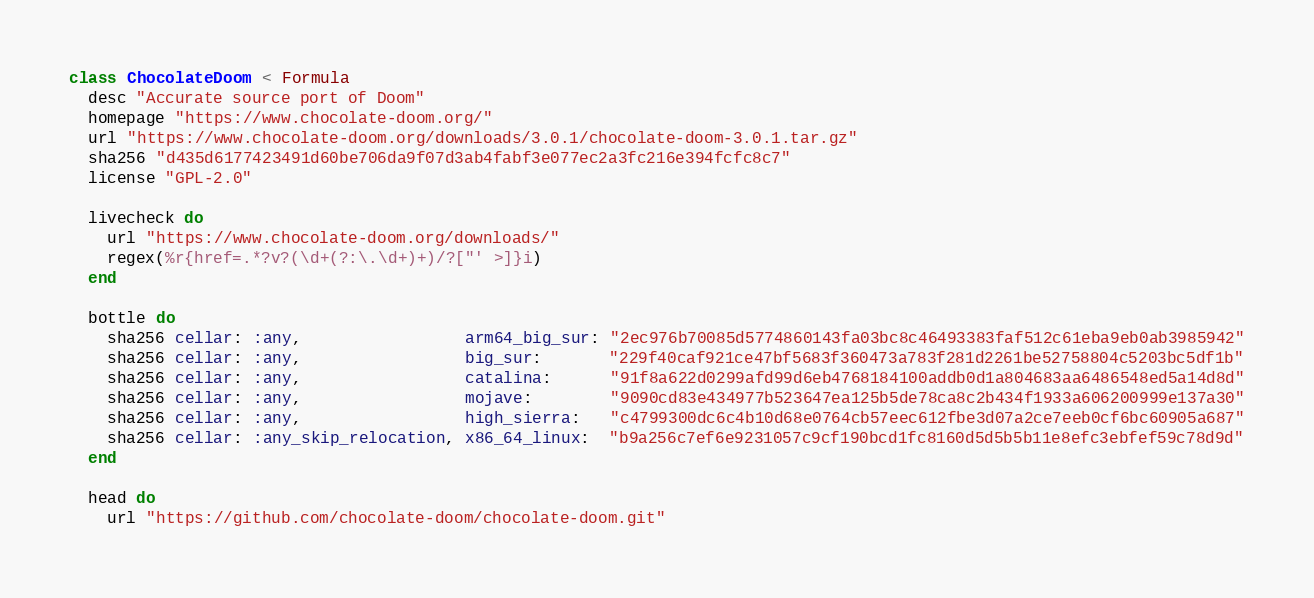<code> <loc_0><loc_0><loc_500><loc_500><_Ruby_>class ChocolateDoom < Formula
  desc "Accurate source port of Doom"
  homepage "https://www.chocolate-doom.org/"
  url "https://www.chocolate-doom.org/downloads/3.0.1/chocolate-doom-3.0.1.tar.gz"
  sha256 "d435d6177423491d60be706da9f07d3ab4fabf3e077ec2a3fc216e394fcfc8c7"
  license "GPL-2.0"

  livecheck do
    url "https://www.chocolate-doom.org/downloads/"
    regex(%r{href=.*?v?(\d+(?:\.\d+)+)/?["' >]}i)
  end

  bottle do
    sha256 cellar: :any,                 arm64_big_sur: "2ec976b70085d5774860143fa03bc8c46493383faf512c61eba9eb0ab3985942"
    sha256 cellar: :any,                 big_sur:       "229f40caf921ce47bf5683f360473a783f281d2261be52758804c5203bc5df1b"
    sha256 cellar: :any,                 catalina:      "91f8a622d0299afd99d6eb4768184100addb0d1a804683aa6486548ed5a14d8d"
    sha256 cellar: :any,                 mojave:        "9090cd83e434977b523647ea125b5de78ca8c2b434f1933a606200999e137a30"
    sha256 cellar: :any,                 high_sierra:   "c4799300dc6c4b10d68e0764cb57eec612fbe3d07a2ce7eeb0cf6bc60905a687"
    sha256 cellar: :any_skip_relocation, x86_64_linux:  "b9a256c7ef6e9231057c9cf190bcd1fc8160d5d5b5b11e8efc3ebfef59c78d9d"
  end

  head do
    url "https://github.com/chocolate-doom/chocolate-doom.git"
</code> 